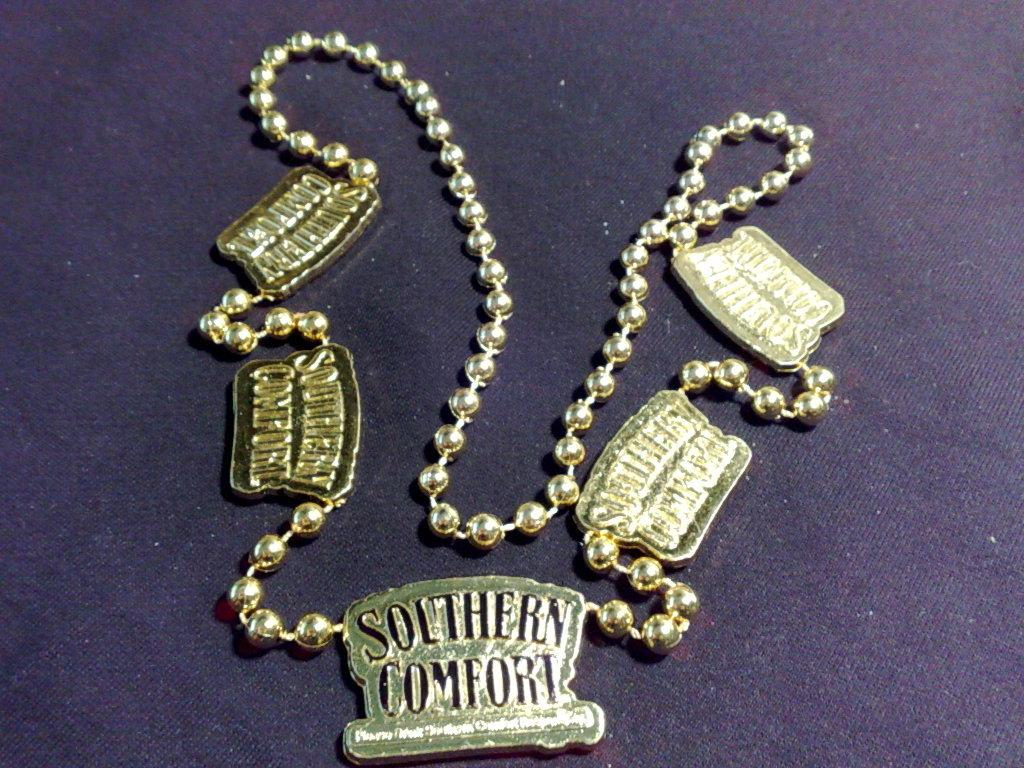Provide a one-sentence caption for the provided image. A gold colored necklace has several charms that say Southern Comfort on it. 